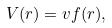<formula> <loc_0><loc_0><loc_500><loc_500>V ( r ) = v f ( r ) ,</formula> 